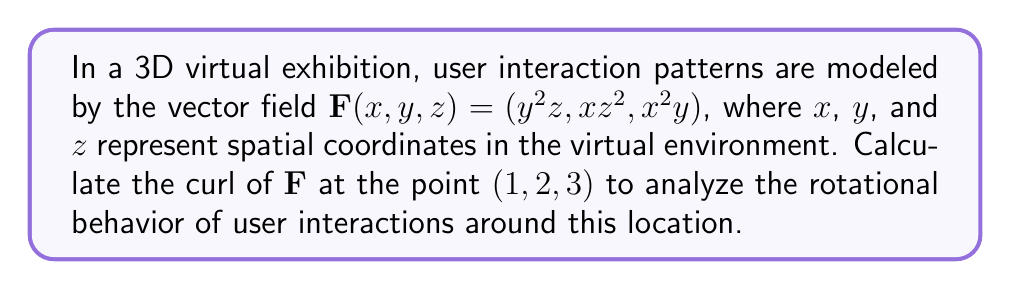Show me your answer to this math problem. To find the curl of the vector field $\mathbf{F}(x,y,z) = (y^2z, xz^2, x^2y)$, we need to follow these steps:

1) The curl of a vector field $\mathbf{F}(x,y,z) = (F_x, F_y, F_z)$ is defined as:

   $$\text{curl}\mathbf{F} = \nabla \times \mathbf{F} = \left(\frac{\partial F_z}{\partial y} - \frac{\partial F_y}{\partial z}, \frac{\partial F_x}{\partial z} - \frac{\partial F_z}{\partial x}, \frac{\partial F_y}{\partial x} - \frac{\partial F_x}{\partial y}\right)$$

2) For our vector field:
   $F_x = y^2z$
   $F_y = xz^2$
   $F_z = x^2y$

3) Let's calculate each component:

   a) $\frac{\partial F_z}{\partial y} - \frac{\partial F_y}{\partial z}$:
      $\frac{\partial F_z}{\partial y} = x^2$
      $\frac{\partial F_y}{\partial z} = 2xz$
      First component: $x^2 - 2xz$

   b) $\frac{\partial F_x}{\partial z} - \frac{\partial F_z}{\partial x}$:
      $\frac{\partial F_x}{\partial z} = y^2$
      $\frac{\partial F_z}{\partial x} = 2xy$
      Second component: $y^2 - 2xy$

   c) $\frac{\partial F_y}{\partial x} - \frac{\partial F_x}{\partial y}$:
      $\frac{\partial F_y}{\partial x} = z^2$
      $\frac{\partial F_x}{\partial y} = 2yz$
      Third component: $z^2 - 2yz$

4) Therefore, the curl of $\mathbf{F}$ is:
   $$\text{curl}\mathbf{F} = (x^2 - 2xz, y^2 - 2xy, z^2 - 2yz)$$

5) To find the curl at the point $(1, 2, 3)$, we substitute these values:
   $$\text{curl}\mathbf{F}(1,2,3) = ((1)^2 - 2(1)(3), (2)^2 - 2(1)(2), (3)^2 - 2(2)(3))$$
   $$= (1 - 6, 4 - 4, 9 - 12)$$
   $$= (-5, 0, -3)$$

This result indicates the rotational behavior of user interactions around the point (1, 2, 3) in the virtual environment.
Answer: $(-5, 0, -3)$ 